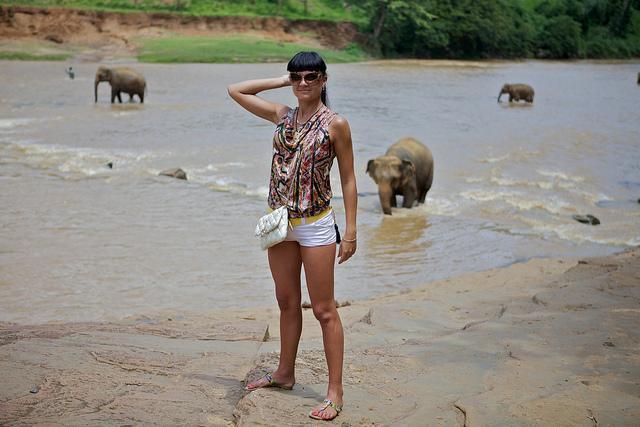Why is the woman holding her hand to her head?
Select the accurate answer and provide explanation: 'Answer: answer
Rationale: rationale.'
Options: To direct, to wave, to pose, to dance. Answer: to pose.
Rationale: The woman is an influencer and wants the best angle. 